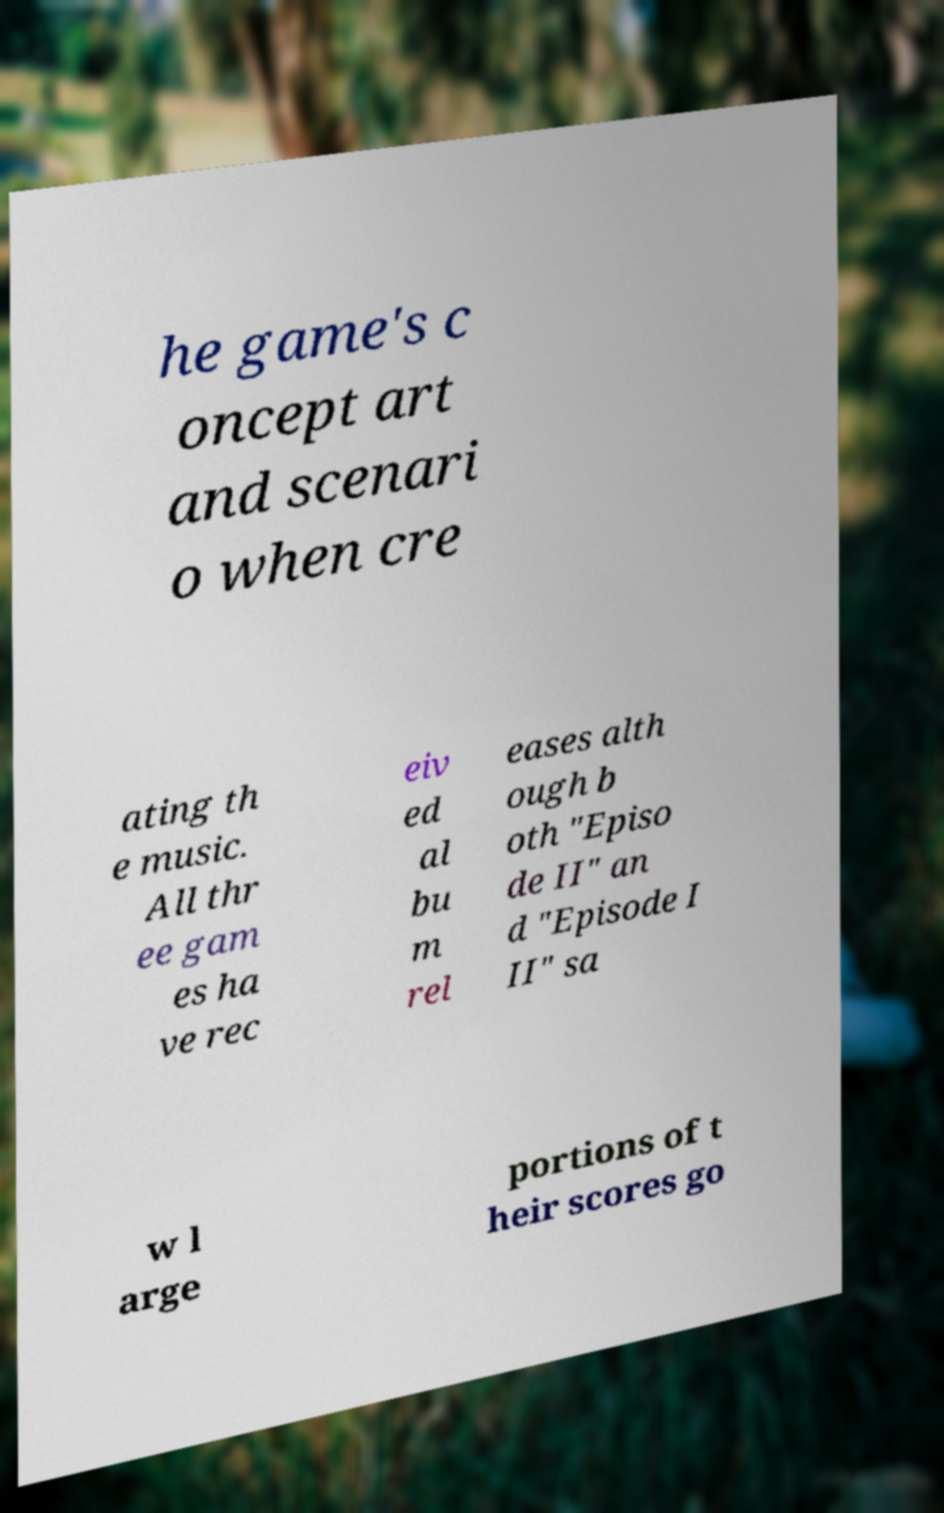Could you assist in decoding the text presented in this image and type it out clearly? he game's c oncept art and scenari o when cre ating th e music. All thr ee gam es ha ve rec eiv ed al bu m rel eases alth ough b oth "Episo de II" an d "Episode I II" sa w l arge portions of t heir scores go 